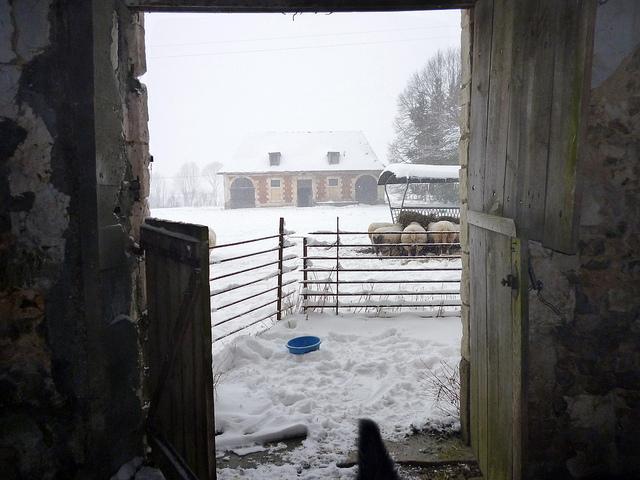How many black sheep are there in the picture?
Give a very brief answer. 0. How many people are in the picture?
Give a very brief answer. 0. 